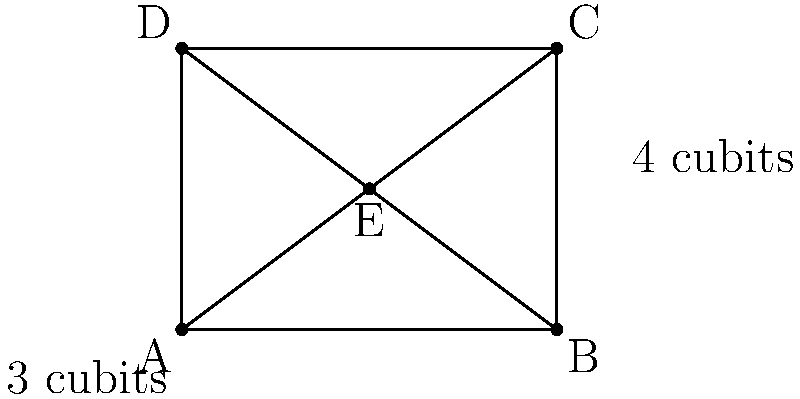In designing a tapestry depicting the layout of Solomon's Temple, you're working with congruent triangles. The tapestry is rectangular, measuring 4 cubits wide and 3 cubits tall. If point E is the exact center of the tapestry, what is the area of triangle ADE in square cubits? To solve this problem, let's follow these steps:

1) First, we need to recognize that the rectangle ABCD is divided into four congruent triangles by its diagonals. Point E is at the intersection of these diagonals.

2) Since E is the center of the rectangle, AE = EC and DE = EB. This means triangle ADE is congruent to the other three triangles.

3) The area of the entire rectangle is:
   $Area_{ABCD} = 4 \times 3 = 12$ square cubits

4) Since there are four congruent triangles, each triangle (including ADE) has an area equal to one-fourth of the rectangle's area:

   $Area_{ADE} = \frac{1}{4} \times Area_{ABCD} = \frac{1}{4} \times 12 = 3$ square cubits

5) We can verify this using the formula for the area of a triangle:
   $Area = \frac{1}{2} \times base \times height$

   The base (AD) is 3 cubits, and the height (perpendicular from E to AD) is 2 cubits.

   $Area_{ADE} = \frac{1}{2} \times 3 \times 2 = 3$ square cubits

Therefore, the area of triangle ADE is 3 square cubits.
Answer: 3 square cubits 